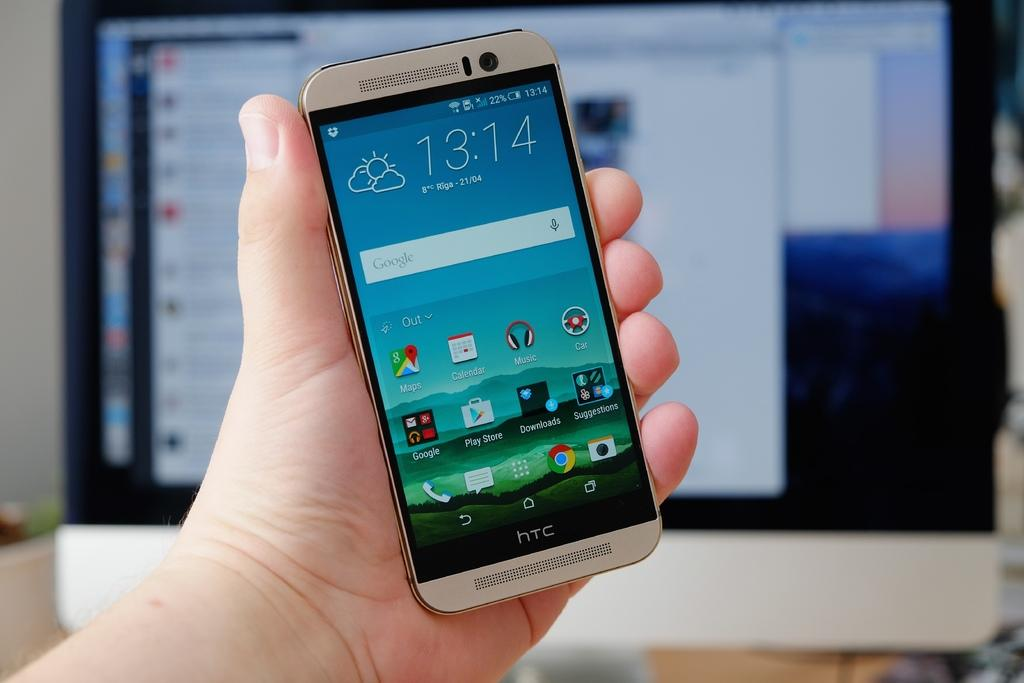<image>
Write a terse but informative summary of the picture. the front of an htc phone with 13:14 as the time on the screen 